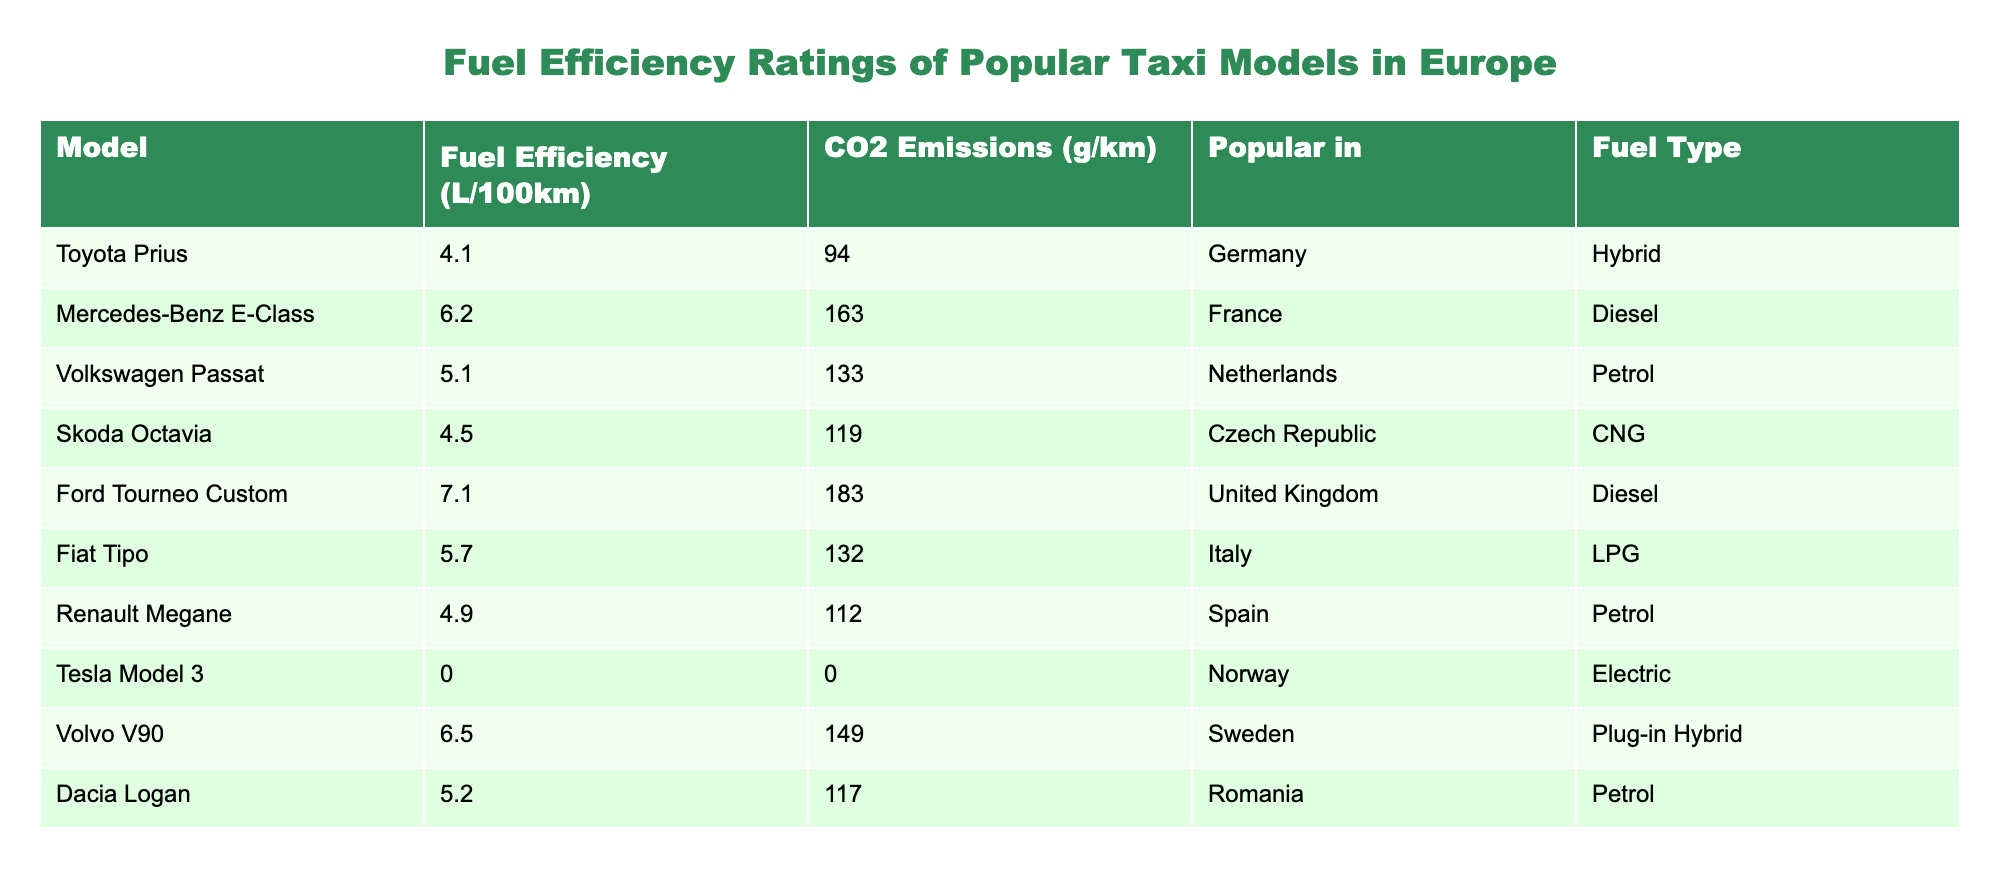What is the fuel efficiency of the Toyota Prius? The fuel efficiency of the Toyota Prius is listed in the table under the "Fuel Efficiency (L/100km)" column. It shows a value of 4.1.
Answer: 4.1 Which taxi model has the highest CO2 emissions? To find the taxi model with the highest CO2 emissions, we compare all the values in the "CO2 Emissions (g/km)" column. The Ford Tourneo Custom has the highest value at 183.
Answer: Ford Tourneo Custom Is the Skoda Octavia popular in Germany? Checking the "Popular in" column, it states that the Skoda Octavia is popular in the Czech Republic, not Germany.
Answer: No What is the average fuel efficiency of the diesel taxi models? First, identify the diesel models: Mercedes-Benz E-Class (6.2), Ford Tourneo Custom (7.1). Adding these, we have 6.2 + 7.1 = 13.3. Since there are 2 models, the average is 13.3 / 2 = 6.65.
Answer: 6.65 Does the Tesla Model 3 have any CO2 emissions? The "CO2 Emissions (g/km)" column shows that the Tesla Model 3 has a CO2 emissions value of 0, indicating it produces no emissions.
Answer: Yes Which fuel type is most commonly associated with popular taxi models in Europe? Analyzing the "Fuel Type" column, we see varied types, but petrol appears in Volkswagen Passat, Renault Megane, and Dacia Logan. Counting these instances, petrol has 3 entries, whereas other types are less frequent.
Answer: Petrol If we consider only petrol models, what is their collective CO2 emissions? The petrol models include Volkswagen Passat (133), Renault Megane (112), and Dacia Logan (117). Adding these figures gives: 133 + 112 + 117 = 362.
Answer: 362 Which model has the lowest fuel efficiency rating and what is that rating? By scanning through the "Fuel Efficiency (L/100km)" column, we find that the Tesla Model 3 has a fuel efficiency rating of 0, which is the lowest.
Answer: Tesla Model 3, 0 Is the Dacia Logan more fuel-efficient than the Mercedes-Benz E-Class? Compare their fuel efficiency values: Dacia Logan is 5.2 and the Mercedes-Benz E-Class is 6.2. Since 5.2 is less than 6.2, the Dacia Logan is indeed more fuel-efficient.
Answer: Yes 